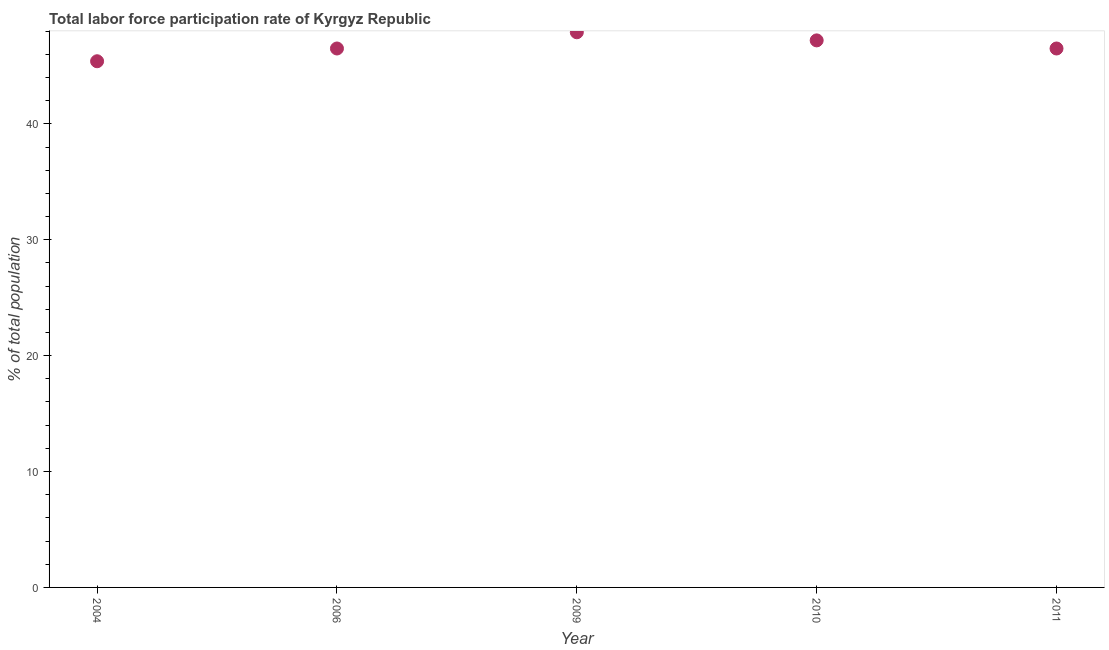What is the total labor force participation rate in 2010?
Your answer should be compact. 47.2. Across all years, what is the maximum total labor force participation rate?
Offer a terse response. 47.9. Across all years, what is the minimum total labor force participation rate?
Give a very brief answer. 45.4. What is the sum of the total labor force participation rate?
Your answer should be compact. 233.5. What is the difference between the total labor force participation rate in 2006 and 2010?
Give a very brief answer. -0.7. What is the average total labor force participation rate per year?
Offer a terse response. 46.7. What is the median total labor force participation rate?
Offer a very short reply. 46.5. What is the ratio of the total labor force participation rate in 2009 to that in 2010?
Offer a terse response. 1.01. Is the total labor force participation rate in 2004 less than that in 2010?
Make the answer very short. Yes. Is the difference between the total labor force participation rate in 2006 and 2009 greater than the difference between any two years?
Your answer should be compact. No. What is the difference between the highest and the second highest total labor force participation rate?
Provide a succinct answer. 0.7. How many dotlines are there?
Provide a short and direct response. 1. What is the difference between two consecutive major ticks on the Y-axis?
Ensure brevity in your answer.  10. Are the values on the major ticks of Y-axis written in scientific E-notation?
Offer a terse response. No. Does the graph contain any zero values?
Provide a short and direct response. No. What is the title of the graph?
Provide a short and direct response. Total labor force participation rate of Kyrgyz Republic. What is the label or title of the Y-axis?
Your answer should be compact. % of total population. What is the % of total population in 2004?
Offer a terse response. 45.4. What is the % of total population in 2006?
Ensure brevity in your answer.  46.5. What is the % of total population in 2009?
Your answer should be compact. 47.9. What is the % of total population in 2010?
Provide a short and direct response. 47.2. What is the % of total population in 2011?
Your answer should be compact. 46.5. What is the difference between the % of total population in 2004 and 2006?
Provide a short and direct response. -1.1. What is the difference between the % of total population in 2004 and 2009?
Keep it short and to the point. -2.5. What is the difference between the % of total population in 2006 and 2009?
Provide a succinct answer. -1.4. What is the difference between the % of total population in 2006 and 2010?
Keep it short and to the point. -0.7. What is the difference between the % of total population in 2006 and 2011?
Your response must be concise. 0. What is the difference between the % of total population in 2009 and 2010?
Provide a succinct answer. 0.7. What is the difference between the % of total population in 2010 and 2011?
Provide a short and direct response. 0.7. What is the ratio of the % of total population in 2004 to that in 2006?
Ensure brevity in your answer.  0.98. What is the ratio of the % of total population in 2004 to that in 2009?
Offer a terse response. 0.95. What is the ratio of the % of total population in 2004 to that in 2011?
Your answer should be very brief. 0.98. 